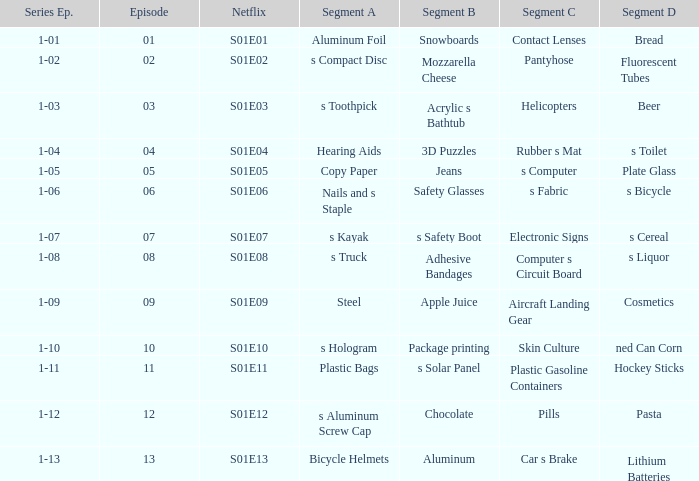What is the Netflix number having a series episode of 1-01? S01E01. 